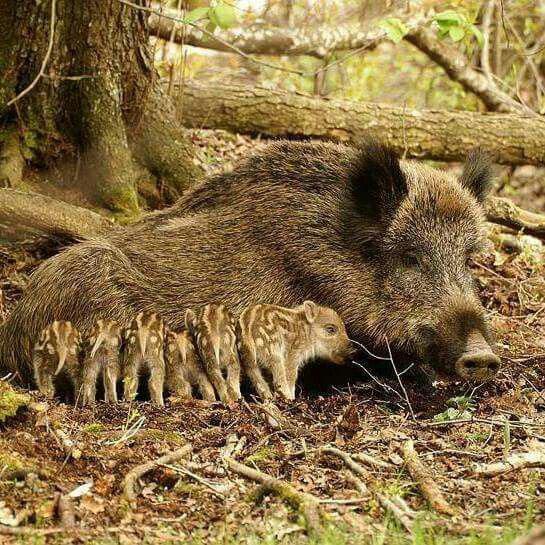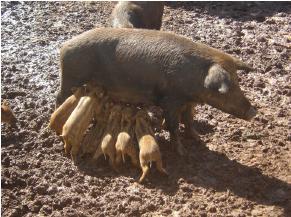The first image is the image on the left, the second image is the image on the right. Given the left and right images, does the statement "The left image contains no more than five wild boars." hold true? Answer yes or no. No. The first image is the image on the left, the second image is the image on the right. Considering the images on both sides, is "Piglets are standing beside an adult pig in both images." valid? Answer yes or no. Yes. 